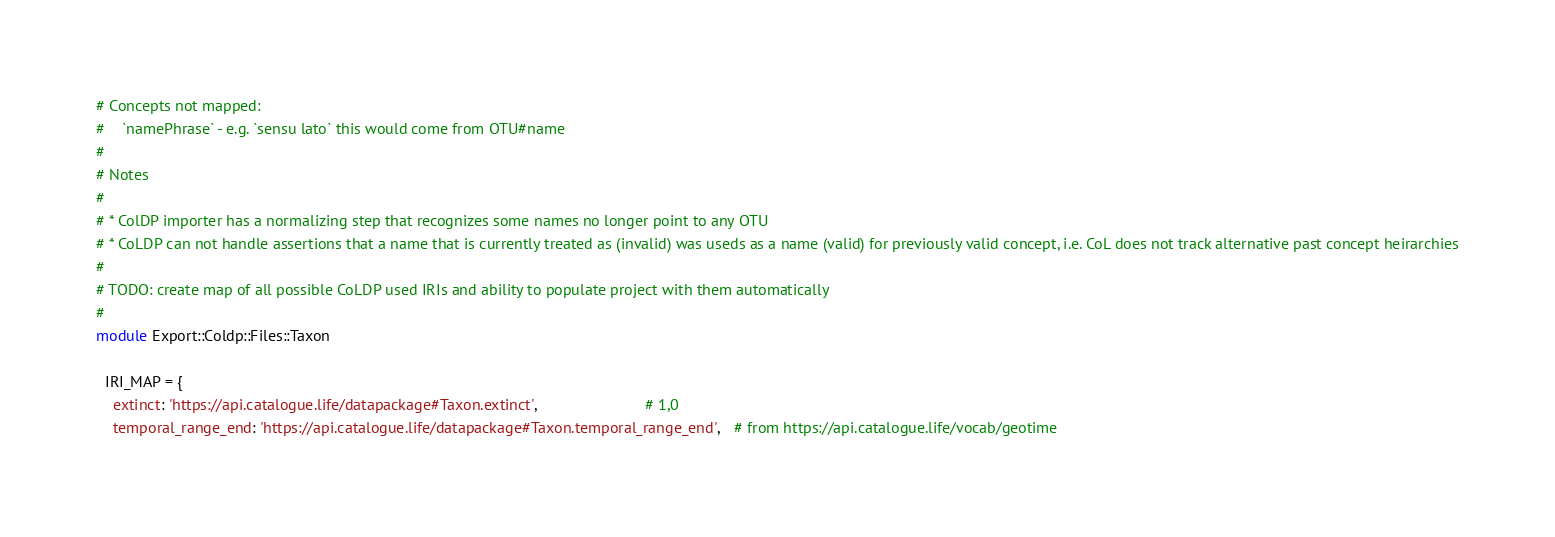Convert code to text. <code><loc_0><loc_0><loc_500><loc_500><_Ruby_># Concepts not mapped:
#    `namePhrase` - e.g. `sensu lato` this would come from OTU#name
#
# Notes
#
# * ColDP importer has a normalizing step that recognizes some names no longer point to any OTU
# * CoLDP can not handle assertions that a name that is currently treated as (invalid) was useds as a name (valid) for previously valid concept, i.e. CoL does not track alternative past concept heirarchies
#
# TODO: create map of all possible CoLDP used IRIs and ability to populate project with them automatically
#
module Export::Coldp::Files::Taxon

  IRI_MAP = {
    extinct: 'https://api.catalogue.life/datapackage#Taxon.extinct',                         # 1,0
    temporal_range_end: 'https://api.catalogue.life/datapackage#Taxon.temporal_range_end',   # from https://api.catalogue.life/vocab/geotime</code> 